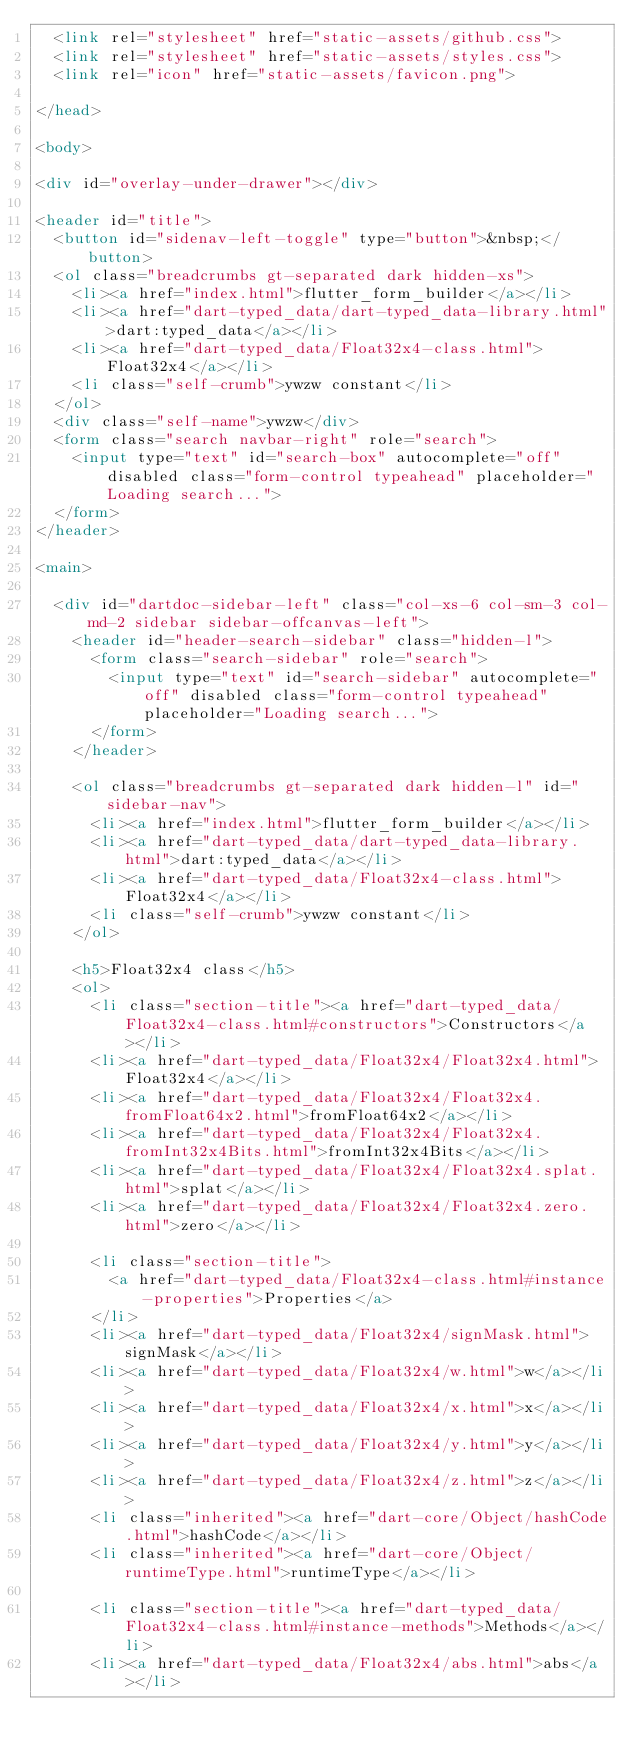Convert code to text. <code><loc_0><loc_0><loc_500><loc_500><_HTML_>  <link rel="stylesheet" href="static-assets/github.css">
  <link rel="stylesheet" href="static-assets/styles.css">
  <link rel="icon" href="static-assets/favicon.png">
  
</head>

<body>

<div id="overlay-under-drawer"></div>

<header id="title">
  <button id="sidenav-left-toggle" type="button">&nbsp;</button>
  <ol class="breadcrumbs gt-separated dark hidden-xs">
    <li><a href="index.html">flutter_form_builder</a></li>
    <li><a href="dart-typed_data/dart-typed_data-library.html">dart:typed_data</a></li>
    <li><a href="dart-typed_data/Float32x4-class.html">Float32x4</a></li>
    <li class="self-crumb">ywzw constant</li>
  </ol>
  <div class="self-name">ywzw</div>
  <form class="search navbar-right" role="search">
    <input type="text" id="search-box" autocomplete="off" disabled class="form-control typeahead" placeholder="Loading search...">
  </form>
</header>

<main>

  <div id="dartdoc-sidebar-left" class="col-xs-6 col-sm-3 col-md-2 sidebar sidebar-offcanvas-left">
    <header id="header-search-sidebar" class="hidden-l">
      <form class="search-sidebar" role="search">
        <input type="text" id="search-sidebar" autocomplete="off" disabled class="form-control typeahead" placeholder="Loading search...">
      </form>
    </header>
    
    <ol class="breadcrumbs gt-separated dark hidden-l" id="sidebar-nav">
      <li><a href="index.html">flutter_form_builder</a></li>
      <li><a href="dart-typed_data/dart-typed_data-library.html">dart:typed_data</a></li>
      <li><a href="dart-typed_data/Float32x4-class.html">Float32x4</a></li>
      <li class="self-crumb">ywzw constant</li>
    </ol>
    
    <h5>Float32x4 class</h5>
    <ol>
      <li class="section-title"><a href="dart-typed_data/Float32x4-class.html#constructors">Constructors</a></li>
      <li><a href="dart-typed_data/Float32x4/Float32x4.html">Float32x4</a></li>
      <li><a href="dart-typed_data/Float32x4/Float32x4.fromFloat64x2.html">fromFloat64x2</a></li>
      <li><a href="dart-typed_data/Float32x4/Float32x4.fromInt32x4Bits.html">fromInt32x4Bits</a></li>
      <li><a href="dart-typed_data/Float32x4/Float32x4.splat.html">splat</a></li>
      <li><a href="dart-typed_data/Float32x4/Float32x4.zero.html">zero</a></li>
    
      <li class="section-title">
        <a href="dart-typed_data/Float32x4-class.html#instance-properties">Properties</a>
      </li>
      <li><a href="dart-typed_data/Float32x4/signMask.html">signMask</a></li>
      <li><a href="dart-typed_data/Float32x4/w.html">w</a></li>
      <li><a href="dart-typed_data/Float32x4/x.html">x</a></li>
      <li><a href="dart-typed_data/Float32x4/y.html">y</a></li>
      <li><a href="dart-typed_data/Float32x4/z.html">z</a></li>
      <li class="inherited"><a href="dart-core/Object/hashCode.html">hashCode</a></li>
      <li class="inherited"><a href="dart-core/Object/runtimeType.html">runtimeType</a></li>
    
      <li class="section-title"><a href="dart-typed_data/Float32x4-class.html#instance-methods">Methods</a></li>
      <li><a href="dart-typed_data/Float32x4/abs.html">abs</a></li></code> 